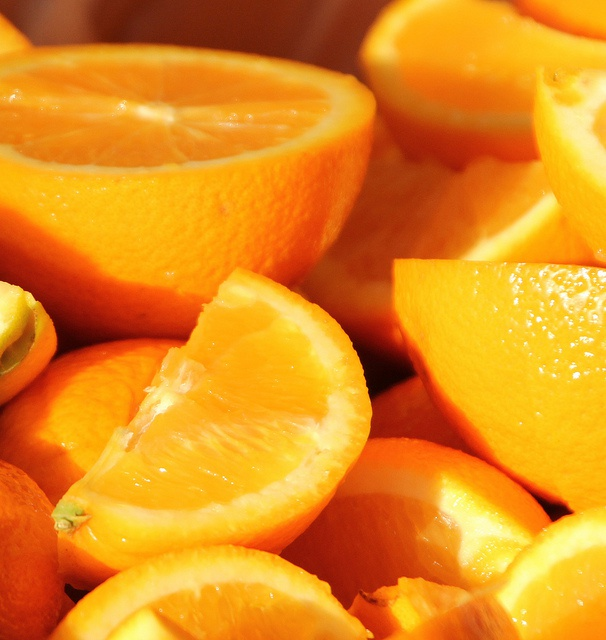Describe the objects in this image and their specific colors. I can see orange in maroon, orange, red, and brown tones, orange in maroon, orange, gold, and red tones, orange in maroon, gold, orange, and khaki tones, orange in maroon, brown, red, orange, and gold tones, and orange in maroon, red, brown, orange, and khaki tones in this image. 